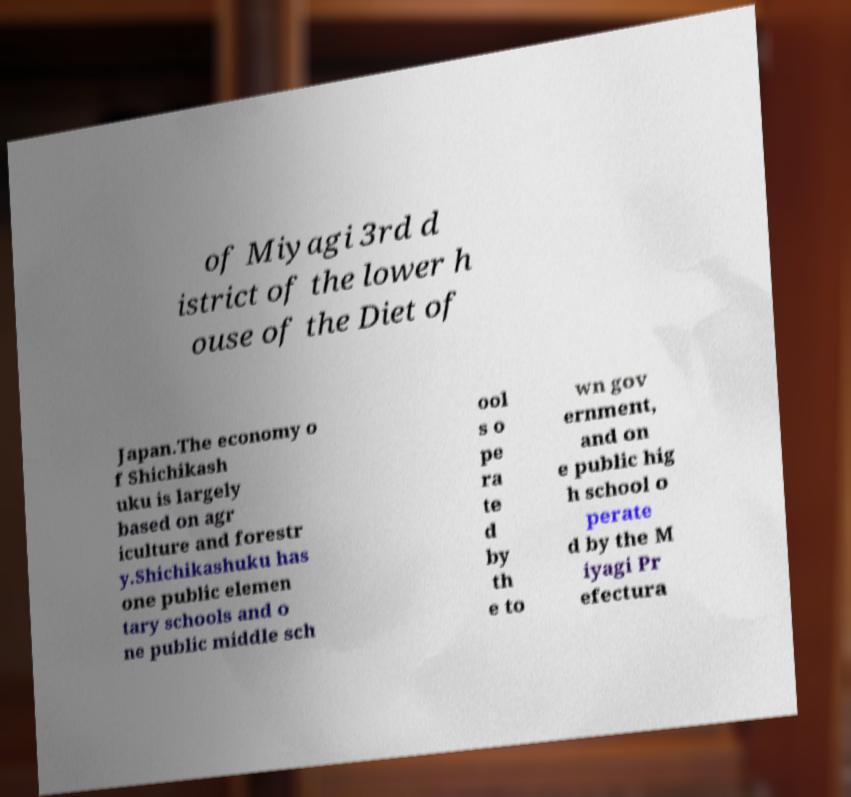Can you read and provide the text displayed in the image?This photo seems to have some interesting text. Can you extract and type it out for me? of Miyagi 3rd d istrict of the lower h ouse of the Diet of Japan.The economy o f Shichikash uku is largely based on agr iculture and forestr y.Shichikashuku has one public elemen tary schools and o ne public middle sch ool s o pe ra te d by th e to wn gov ernment, and on e public hig h school o perate d by the M iyagi Pr efectura 